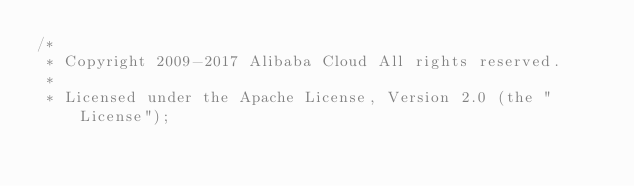<code> <loc_0><loc_0><loc_500><loc_500><_C++_>/*
 * Copyright 2009-2017 Alibaba Cloud All rights reserved.
 * 
 * Licensed under the Apache License, Version 2.0 (the "License");</code> 